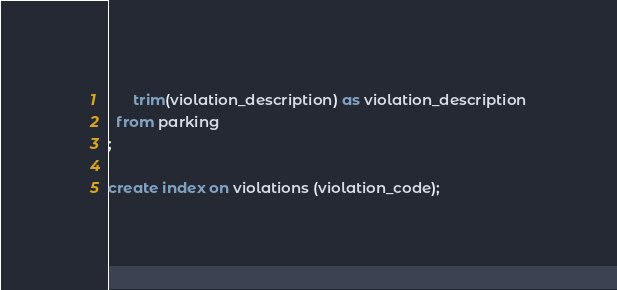Convert code to text. <code><loc_0><loc_0><loc_500><loc_500><_SQL_>      trim(violation_description) as violation_description
  from parking
;

create index on violations (violation_code);
</code> 